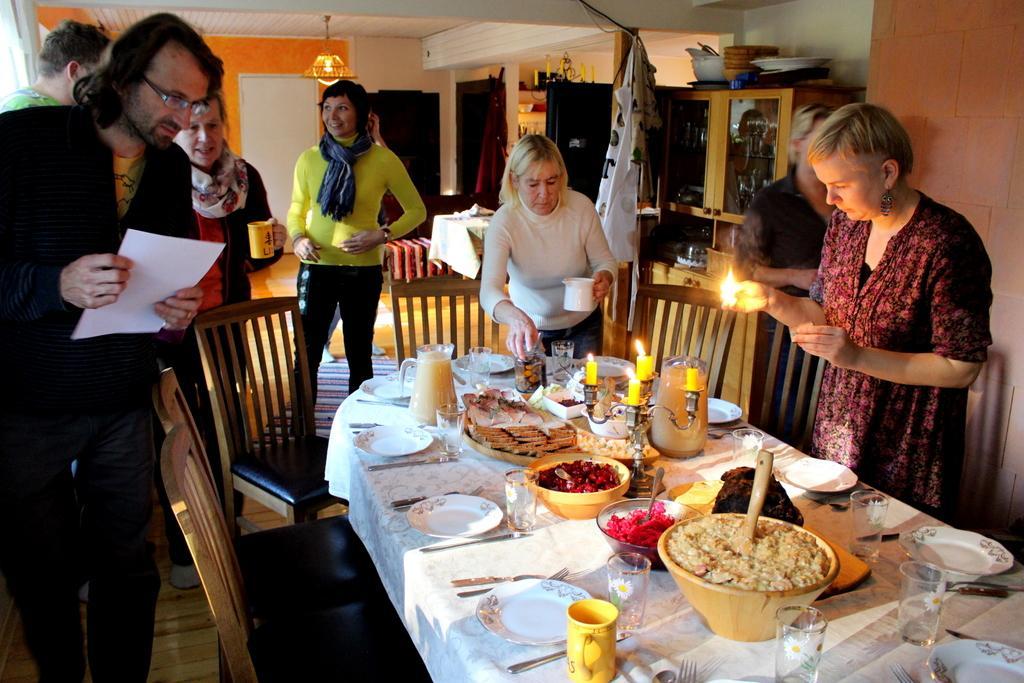Describe this image in one or two sentences. In this picture we can see group of people they are all standing, in front of them we can see chair, plates, forks, knives, cups and some food items on the table. In the background we can see light and sofa. 